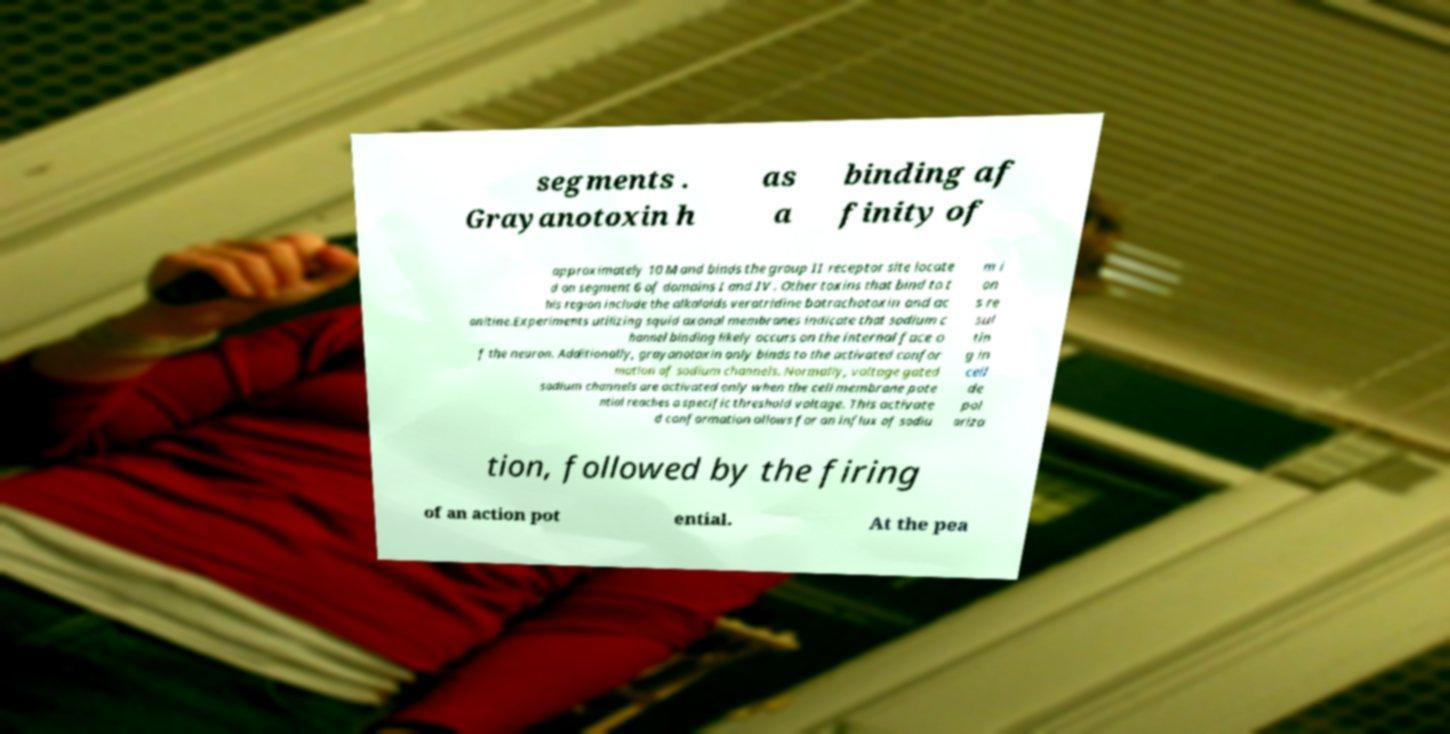Please read and relay the text visible in this image. What does it say? segments . Grayanotoxin h as a binding af finity of approximately 10 M and binds the group II receptor site locate d on segment 6 of domains I and IV . Other toxins that bind to t his region include the alkaloids veratridine batrachotoxin and ac onitine.Experiments utilizing squid axonal membranes indicate that sodium c hannel binding likely occurs on the internal face o f the neuron. Additionally, grayanotoxin only binds to the activated confor mation of sodium channels. Normally, voltage gated sodium channels are activated only when the cell membrane pote ntial reaches a specific threshold voltage. This activate d conformation allows for an influx of sodiu m i on s re sul tin g in cell de pol ariza tion, followed by the firing of an action pot ential. At the pea 